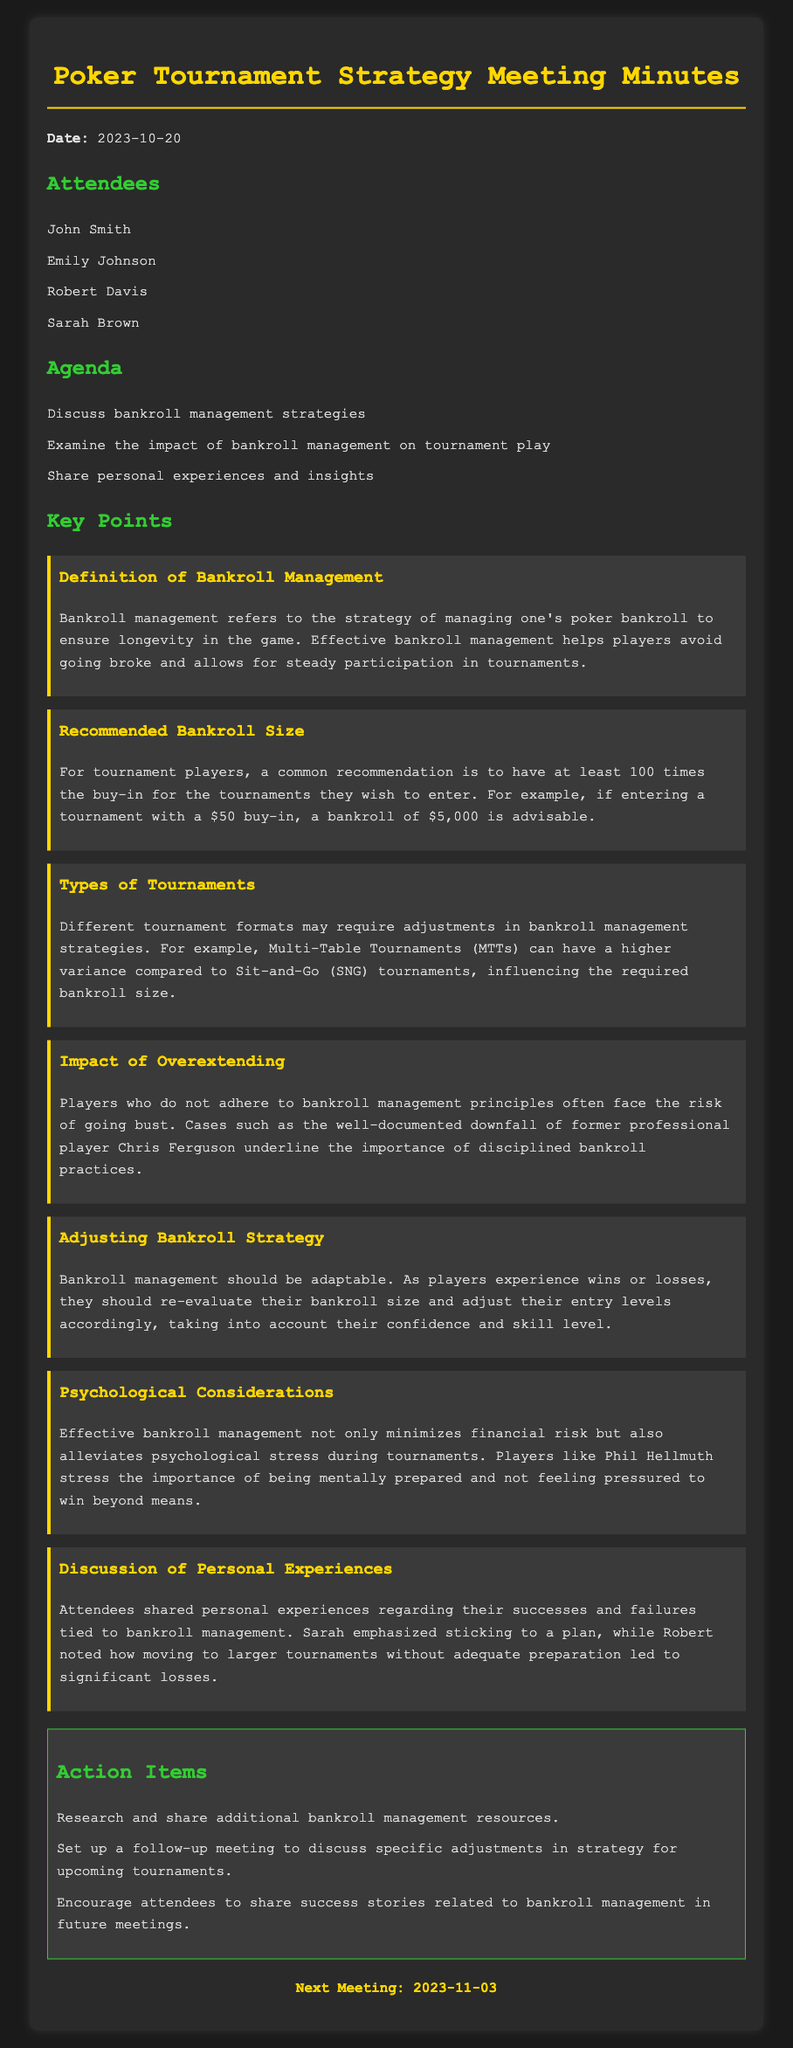what was the date of the meeting? The date of the meeting is explicitly stated in the document.
Answer: 2023-10-20 who emphasized sticking to a plan during the discussion? The document notes specific personal experiences shared by attendees, indicating who emphasized certain points.
Answer: Sarah what is the advised bankroll size for a $50 buy-in tournament? The document provides a calculation related to bankroll size for specific buy-ins.
Answer: $5,000 what should players do as their bankroll fluctuates? The document discusses adjusting bankroll strategies based on wins or losses.
Answer: Re-evaluate their bankroll size what type of tournament has higher variance according to the minutes? The document mentions differences in tournament formats and their variance.
Answer: Multi-Table Tournaments (MTTs) what is a key psychological consideration in bankroll management? The document discusses psychological aspects and their importance for players during tournaments.
Answer: Alleviates psychological stress how often should players share success stories related to bankroll management? The document recommends actions for future meetings related to personal experiences.
Answer: In future meetings what are the attendees of the meeting? The document lists the names of the attendees.
Answer: John Smith, Emily Johnson, Robert Davis, Sarah Brown 